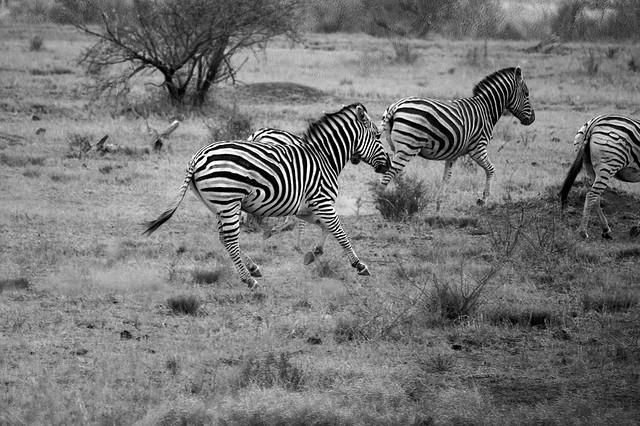How many zebras are running in the savannah area?

Choices:
A) four
B) one
C) two
D) five two 